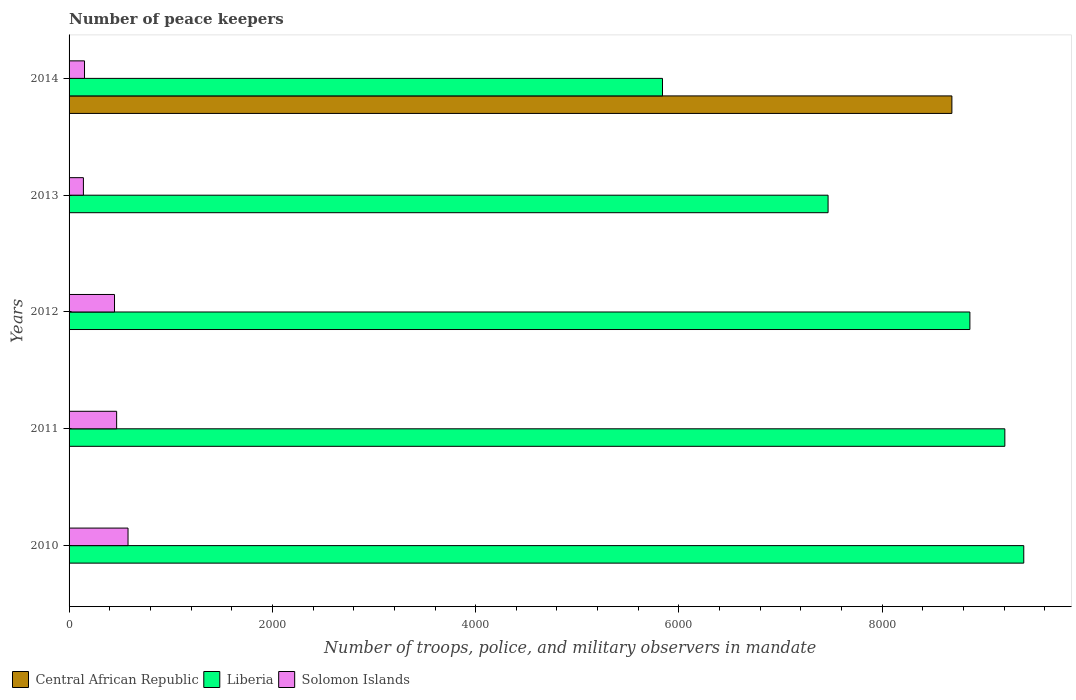How many different coloured bars are there?
Offer a very short reply. 3. Are the number of bars on each tick of the Y-axis equal?
Your answer should be compact. Yes. How many bars are there on the 4th tick from the bottom?
Offer a very short reply. 3. What is the label of the 1st group of bars from the top?
Offer a very short reply. 2014. What is the number of peace keepers in in Solomon Islands in 2012?
Offer a very short reply. 447. Across all years, what is the maximum number of peace keepers in in Central African Republic?
Make the answer very short. 8685. Across all years, what is the minimum number of peace keepers in in Solomon Islands?
Offer a very short reply. 141. What is the total number of peace keepers in in Solomon Islands in the graph?
Ensure brevity in your answer.  1788. What is the difference between the number of peace keepers in in Solomon Islands in 2012 and that in 2013?
Offer a very short reply. 306. What is the difference between the number of peace keepers in in Solomon Islands in 2010 and the number of peace keepers in in Liberia in 2013?
Keep it short and to the point. -6887. What is the average number of peace keepers in in Solomon Islands per year?
Keep it short and to the point. 357.6. In the year 2013, what is the difference between the number of peace keepers in in Solomon Islands and number of peace keepers in in Liberia?
Offer a terse response. -7326. In how many years, is the number of peace keepers in in Solomon Islands greater than 400 ?
Your answer should be very brief. 3. What is the ratio of the number of peace keepers in in Liberia in 2011 to that in 2013?
Offer a terse response. 1.23. What is the difference between the highest and the second highest number of peace keepers in in Solomon Islands?
Keep it short and to the point. 112. What is the difference between the highest and the lowest number of peace keepers in in Central African Republic?
Offer a very short reply. 8682. What does the 2nd bar from the top in 2010 represents?
Keep it short and to the point. Liberia. What does the 2nd bar from the bottom in 2012 represents?
Your answer should be compact. Liberia. Is it the case that in every year, the sum of the number of peace keepers in in Central African Republic and number of peace keepers in in Solomon Islands is greater than the number of peace keepers in in Liberia?
Provide a succinct answer. No. What is the difference between two consecutive major ticks on the X-axis?
Provide a succinct answer. 2000. Are the values on the major ticks of X-axis written in scientific E-notation?
Ensure brevity in your answer.  No. How many legend labels are there?
Ensure brevity in your answer.  3. How are the legend labels stacked?
Offer a terse response. Horizontal. What is the title of the graph?
Provide a succinct answer. Number of peace keepers. What is the label or title of the X-axis?
Keep it short and to the point. Number of troops, police, and military observers in mandate. What is the label or title of the Y-axis?
Your answer should be compact. Years. What is the Number of troops, police, and military observers in mandate in Liberia in 2010?
Your answer should be compact. 9392. What is the Number of troops, police, and military observers in mandate of Solomon Islands in 2010?
Provide a short and direct response. 580. What is the Number of troops, police, and military observers in mandate of Liberia in 2011?
Your answer should be compact. 9206. What is the Number of troops, police, and military observers in mandate of Solomon Islands in 2011?
Ensure brevity in your answer.  468. What is the Number of troops, police, and military observers in mandate of Central African Republic in 2012?
Keep it short and to the point. 4. What is the Number of troops, police, and military observers in mandate of Liberia in 2012?
Offer a very short reply. 8862. What is the Number of troops, police, and military observers in mandate of Solomon Islands in 2012?
Give a very brief answer. 447. What is the Number of troops, police, and military observers in mandate in Central African Republic in 2013?
Offer a terse response. 4. What is the Number of troops, police, and military observers in mandate in Liberia in 2013?
Keep it short and to the point. 7467. What is the Number of troops, police, and military observers in mandate in Solomon Islands in 2013?
Keep it short and to the point. 141. What is the Number of troops, police, and military observers in mandate of Central African Republic in 2014?
Keep it short and to the point. 8685. What is the Number of troops, police, and military observers in mandate in Liberia in 2014?
Ensure brevity in your answer.  5838. What is the Number of troops, police, and military observers in mandate in Solomon Islands in 2014?
Offer a very short reply. 152. Across all years, what is the maximum Number of troops, police, and military observers in mandate of Central African Republic?
Give a very brief answer. 8685. Across all years, what is the maximum Number of troops, police, and military observers in mandate of Liberia?
Your answer should be very brief. 9392. Across all years, what is the maximum Number of troops, police, and military observers in mandate of Solomon Islands?
Your response must be concise. 580. Across all years, what is the minimum Number of troops, police, and military observers in mandate of Central African Republic?
Your response must be concise. 3. Across all years, what is the minimum Number of troops, police, and military observers in mandate of Liberia?
Your response must be concise. 5838. Across all years, what is the minimum Number of troops, police, and military observers in mandate in Solomon Islands?
Make the answer very short. 141. What is the total Number of troops, police, and military observers in mandate in Central African Republic in the graph?
Provide a succinct answer. 8700. What is the total Number of troops, police, and military observers in mandate in Liberia in the graph?
Ensure brevity in your answer.  4.08e+04. What is the total Number of troops, police, and military observers in mandate in Solomon Islands in the graph?
Ensure brevity in your answer.  1788. What is the difference between the Number of troops, police, and military observers in mandate in Central African Republic in 2010 and that in 2011?
Offer a terse response. -1. What is the difference between the Number of troops, police, and military observers in mandate of Liberia in 2010 and that in 2011?
Your answer should be compact. 186. What is the difference between the Number of troops, police, and military observers in mandate of Solomon Islands in 2010 and that in 2011?
Offer a terse response. 112. What is the difference between the Number of troops, police, and military observers in mandate of Central African Republic in 2010 and that in 2012?
Provide a short and direct response. -1. What is the difference between the Number of troops, police, and military observers in mandate in Liberia in 2010 and that in 2012?
Keep it short and to the point. 530. What is the difference between the Number of troops, police, and military observers in mandate of Solomon Islands in 2010 and that in 2012?
Provide a short and direct response. 133. What is the difference between the Number of troops, police, and military observers in mandate in Central African Republic in 2010 and that in 2013?
Provide a short and direct response. -1. What is the difference between the Number of troops, police, and military observers in mandate in Liberia in 2010 and that in 2013?
Offer a terse response. 1925. What is the difference between the Number of troops, police, and military observers in mandate in Solomon Islands in 2010 and that in 2013?
Provide a short and direct response. 439. What is the difference between the Number of troops, police, and military observers in mandate of Central African Republic in 2010 and that in 2014?
Make the answer very short. -8682. What is the difference between the Number of troops, police, and military observers in mandate in Liberia in 2010 and that in 2014?
Ensure brevity in your answer.  3554. What is the difference between the Number of troops, police, and military observers in mandate in Solomon Islands in 2010 and that in 2014?
Keep it short and to the point. 428. What is the difference between the Number of troops, police, and military observers in mandate in Central African Republic in 2011 and that in 2012?
Your answer should be compact. 0. What is the difference between the Number of troops, police, and military observers in mandate in Liberia in 2011 and that in 2012?
Your response must be concise. 344. What is the difference between the Number of troops, police, and military observers in mandate in Central African Republic in 2011 and that in 2013?
Your answer should be very brief. 0. What is the difference between the Number of troops, police, and military observers in mandate of Liberia in 2011 and that in 2013?
Offer a terse response. 1739. What is the difference between the Number of troops, police, and military observers in mandate in Solomon Islands in 2011 and that in 2013?
Keep it short and to the point. 327. What is the difference between the Number of troops, police, and military observers in mandate in Central African Republic in 2011 and that in 2014?
Your answer should be very brief. -8681. What is the difference between the Number of troops, police, and military observers in mandate in Liberia in 2011 and that in 2014?
Offer a very short reply. 3368. What is the difference between the Number of troops, police, and military observers in mandate in Solomon Islands in 2011 and that in 2014?
Make the answer very short. 316. What is the difference between the Number of troops, police, and military observers in mandate of Central African Republic in 2012 and that in 2013?
Your answer should be compact. 0. What is the difference between the Number of troops, police, and military observers in mandate in Liberia in 2012 and that in 2013?
Offer a very short reply. 1395. What is the difference between the Number of troops, police, and military observers in mandate of Solomon Islands in 2012 and that in 2013?
Provide a succinct answer. 306. What is the difference between the Number of troops, police, and military observers in mandate in Central African Republic in 2012 and that in 2014?
Provide a succinct answer. -8681. What is the difference between the Number of troops, police, and military observers in mandate of Liberia in 2012 and that in 2014?
Your answer should be very brief. 3024. What is the difference between the Number of troops, police, and military observers in mandate of Solomon Islands in 2012 and that in 2014?
Make the answer very short. 295. What is the difference between the Number of troops, police, and military observers in mandate of Central African Republic in 2013 and that in 2014?
Your answer should be very brief. -8681. What is the difference between the Number of troops, police, and military observers in mandate of Liberia in 2013 and that in 2014?
Offer a very short reply. 1629. What is the difference between the Number of troops, police, and military observers in mandate of Solomon Islands in 2013 and that in 2014?
Provide a short and direct response. -11. What is the difference between the Number of troops, police, and military observers in mandate in Central African Republic in 2010 and the Number of troops, police, and military observers in mandate in Liberia in 2011?
Ensure brevity in your answer.  -9203. What is the difference between the Number of troops, police, and military observers in mandate of Central African Republic in 2010 and the Number of troops, police, and military observers in mandate of Solomon Islands in 2011?
Ensure brevity in your answer.  -465. What is the difference between the Number of troops, police, and military observers in mandate in Liberia in 2010 and the Number of troops, police, and military observers in mandate in Solomon Islands in 2011?
Provide a short and direct response. 8924. What is the difference between the Number of troops, police, and military observers in mandate of Central African Republic in 2010 and the Number of troops, police, and military observers in mandate of Liberia in 2012?
Give a very brief answer. -8859. What is the difference between the Number of troops, police, and military observers in mandate in Central African Republic in 2010 and the Number of troops, police, and military observers in mandate in Solomon Islands in 2012?
Your answer should be compact. -444. What is the difference between the Number of troops, police, and military observers in mandate in Liberia in 2010 and the Number of troops, police, and military observers in mandate in Solomon Islands in 2012?
Provide a succinct answer. 8945. What is the difference between the Number of troops, police, and military observers in mandate of Central African Republic in 2010 and the Number of troops, police, and military observers in mandate of Liberia in 2013?
Your answer should be very brief. -7464. What is the difference between the Number of troops, police, and military observers in mandate of Central African Republic in 2010 and the Number of troops, police, and military observers in mandate of Solomon Islands in 2013?
Your response must be concise. -138. What is the difference between the Number of troops, police, and military observers in mandate of Liberia in 2010 and the Number of troops, police, and military observers in mandate of Solomon Islands in 2013?
Your answer should be very brief. 9251. What is the difference between the Number of troops, police, and military observers in mandate of Central African Republic in 2010 and the Number of troops, police, and military observers in mandate of Liberia in 2014?
Give a very brief answer. -5835. What is the difference between the Number of troops, police, and military observers in mandate of Central African Republic in 2010 and the Number of troops, police, and military observers in mandate of Solomon Islands in 2014?
Give a very brief answer. -149. What is the difference between the Number of troops, police, and military observers in mandate in Liberia in 2010 and the Number of troops, police, and military observers in mandate in Solomon Islands in 2014?
Offer a terse response. 9240. What is the difference between the Number of troops, police, and military observers in mandate in Central African Republic in 2011 and the Number of troops, police, and military observers in mandate in Liberia in 2012?
Make the answer very short. -8858. What is the difference between the Number of troops, police, and military observers in mandate in Central African Republic in 2011 and the Number of troops, police, and military observers in mandate in Solomon Islands in 2012?
Give a very brief answer. -443. What is the difference between the Number of troops, police, and military observers in mandate in Liberia in 2011 and the Number of troops, police, and military observers in mandate in Solomon Islands in 2012?
Your answer should be compact. 8759. What is the difference between the Number of troops, police, and military observers in mandate of Central African Republic in 2011 and the Number of troops, police, and military observers in mandate of Liberia in 2013?
Your answer should be compact. -7463. What is the difference between the Number of troops, police, and military observers in mandate of Central African Republic in 2011 and the Number of troops, police, and military observers in mandate of Solomon Islands in 2013?
Make the answer very short. -137. What is the difference between the Number of troops, police, and military observers in mandate of Liberia in 2011 and the Number of troops, police, and military observers in mandate of Solomon Islands in 2013?
Provide a short and direct response. 9065. What is the difference between the Number of troops, police, and military observers in mandate in Central African Republic in 2011 and the Number of troops, police, and military observers in mandate in Liberia in 2014?
Offer a very short reply. -5834. What is the difference between the Number of troops, police, and military observers in mandate of Central African Republic in 2011 and the Number of troops, police, and military observers in mandate of Solomon Islands in 2014?
Give a very brief answer. -148. What is the difference between the Number of troops, police, and military observers in mandate of Liberia in 2011 and the Number of troops, police, and military observers in mandate of Solomon Islands in 2014?
Ensure brevity in your answer.  9054. What is the difference between the Number of troops, police, and military observers in mandate of Central African Republic in 2012 and the Number of troops, police, and military observers in mandate of Liberia in 2013?
Offer a very short reply. -7463. What is the difference between the Number of troops, police, and military observers in mandate in Central African Republic in 2012 and the Number of troops, police, and military observers in mandate in Solomon Islands in 2013?
Your answer should be compact. -137. What is the difference between the Number of troops, police, and military observers in mandate of Liberia in 2012 and the Number of troops, police, and military observers in mandate of Solomon Islands in 2013?
Offer a terse response. 8721. What is the difference between the Number of troops, police, and military observers in mandate in Central African Republic in 2012 and the Number of troops, police, and military observers in mandate in Liberia in 2014?
Offer a very short reply. -5834. What is the difference between the Number of troops, police, and military observers in mandate in Central African Republic in 2012 and the Number of troops, police, and military observers in mandate in Solomon Islands in 2014?
Your answer should be very brief. -148. What is the difference between the Number of troops, police, and military observers in mandate in Liberia in 2012 and the Number of troops, police, and military observers in mandate in Solomon Islands in 2014?
Your answer should be very brief. 8710. What is the difference between the Number of troops, police, and military observers in mandate of Central African Republic in 2013 and the Number of troops, police, and military observers in mandate of Liberia in 2014?
Your response must be concise. -5834. What is the difference between the Number of troops, police, and military observers in mandate in Central African Republic in 2013 and the Number of troops, police, and military observers in mandate in Solomon Islands in 2014?
Offer a terse response. -148. What is the difference between the Number of troops, police, and military observers in mandate in Liberia in 2013 and the Number of troops, police, and military observers in mandate in Solomon Islands in 2014?
Provide a short and direct response. 7315. What is the average Number of troops, police, and military observers in mandate of Central African Republic per year?
Your answer should be very brief. 1740. What is the average Number of troops, police, and military observers in mandate in Liberia per year?
Offer a very short reply. 8153. What is the average Number of troops, police, and military observers in mandate in Solomon Islands per year?
Provide a succinct answer. 357.6. In the year 2010, what is the difference between the Number of troops, police, and military observers in mandate in Central African Republic and Number of troops, police, and military observers in mandate in Liberia?
Your response must be concise. -9389. In the year 2010, what is the difference between the Number of troops, police, and military observers in mandate in Central African Republic and Number of troops, police, and military observers in mandate in Solomon Islands?
Your response must be concise. -577. In the year 2010, what is the difference between the Number of troops, police, and military observers in mandate in Liberia and Number of troops, police, and military observers in mandate in Solomon Islands?
Offer a terse response. 8812. In the year 2011, what is the difference between the Number of troops, police, and military observers in mandate of Central African Republic and Number of troops, police, and military observers in mandate of Liberia?
Keep it short and to the point. -9202. In the year 2011, what is the difference between the Number of troops, police, and military observers in mandate in Central African Republic and Number of troops, police, and military observers in mandate in Solomon Islands?
Make the answer very short. -464. In the year 2011, what is the difference between the Number of troops, police, and military observers in mandate of Liberia and Number of troops, police, and military observers in mandate of Solomon Islands?
Offer a terse response. 8738. In the year 2012, what is the difference between the Number of troops, police, and military observers in mandate of Central African Republic and Number of troops, police, and military observers in mandate of Liberia?
Your answer should be very brief. -8858. In the year 2012, what is the difference between the Number of troops, police, and military observers in mandate in Central African Republic and Number of troops, police, and military observers in mandate in Solomon Islands?
Your answer should be compact. -443. In the year 2012, what is the difference between the Number of troops, police, and military observers in mandate in Liberia and Number of troops, police, and military observers in mandate in Solomon Islands?
Provide a succinct answer. 8415. In the year 2013, what is the difference between the Number of troops, police, and military observers in mandate of Central African Republic and Number of troops, police, and military observers in mandate of Liberia?
Offer a very short reply. -7463. In the year 2013, what is the difference between the Number of troops, police, and military observers in mandate of Central African Republic and Number of troops, police, and military observers in mandate of Solomon Islands?
Provide a short and direct response. -137. In the year 2013, what is the difference between the Number of troops, police, and military observers in mandate of Liberia and Number of troops, police, and military observers in mandate of Solomon Islands?
Give a very brief answer. 7326. In the year 2014, what is the difference between the Number of troops, police, and military observers in mandate in Central African Republic and Number of troops, police, and military observers in mandate in Liberia?
Offer a very short reply. 2847. In the year 2014, what is the difference between the Number of troops, police, and military observers in mandate in Central African Republic and Number of troops, police, and military observers in mandate in Solomon Islands?
Offer a very short reply. 8533. In the year 2014, what is the difference between the Number of troops, police, and military observers in mandate of Liberia and Number of troops, police, and military observers in mandate of Solomon Islands?
Your response must be concise. 5686. What is the ratio of the Number of troops, police, and military observers in mandate of Central African Republic in 2010 to that in 2011?
Give a very brief answer. 0.75. What is the ratio of the Number of troops, police, and military observers in mandate of Liberia in 2010 to that in 2011?
Keep it short and to the point. 1.02. What is the ratio of the Number of troops, police, and military observers in mandate of Solomon Islands in 2010 to that in 2011?
Offer a terse response. 1.24. What is the ratio of the Number of troops, police, and military observers in mandate of Central African Republic in 2010 to that in 2012?
Make the answer very short. 0.75. What is the ratio of the Number of troops, police, and military observers in mandate of Liberia in 2010 to that in 2012?
Offer a terse response. 1.06. What is the ratio of the Number of troops, police, and military observers in mandate of Solomon Islands in 2010 to that in 2012?
Your response must be concise. 1.3. What is the ratio of the Number of troops, police, and military observers in mandate of Liberia in 2010 to that in 2013?
Offer a terse response. 1.26. What is the ratio of the Number of troops, police, and military observers in mandate in Solomon Islands in 2010 to that in 2013?
Provide a short and direct response. 4.11. What is the ratio of the Number of troops, police, and military observers in mandate of Liberia in 2010 to that in 2014?
Provide a short and direct response. 1.61. What is the ratio of the Number of troops, police, and military observers in mandate of Solomon Islands in 2010 to that in 2014?
Provide a short and direct response. 3.82. What is the ratio of the Number of troops, police, and military observers in mandate in Central African Republic in 2011 to that in 2012?
Ensure brevity in your answer.  1. What is the ratio of the Number of troops, police, and military observers in mandate of Liberia in 2011 to that in 2012?
Offer a terse response. 1.04. What is the ratio of the Number of troops, police, and military observers in mandate in Solomon Islands in 2011 to that in 2012?
Your answer should be very brief. 1.05. What is the ratio of the Number of troops, police, and military observers in mandate of Central African Republic in 2011 to that in 2013?
Provide a short and direct response. 1. What is the ratio of the Number of troops, police, and military observers in mandate in Liberia in 2011 to that in 2013?
Make the answer very short. 1.23. What is the ratio of the Number of troops, police, and military observers in mandate of Solomon Islands in 2011 to that in 2013?
Offer a terse response. 3.32. What is the ratio of the Number of troops, police, and military observers in mandate of Liberia in 2011 to that in 2014?
Make the answer very short. 1.58. What is the ratio of the Number of troops, police, and military observers in mandate in Solomon Islands in 2011 to that in 2014?
Your response must be concise. 3.08. What is the ratio of the Number of troops, police, and military observers in mandate in Liberia in 2012 to that in 2013?
Keep it short and to the point. 1.19. What is the ratio of the Number of troops, police, and military observers in mandate of Solomon Islands in 2012 to that in 2013?
Make the answer very short. 3.17. What is the ratio of the Number of troops, police, and military observers in mandate in Central African Republic in 2012 to that in 2014?
Provide a succinct answer. 0. What is the ratio of the Number of troops, police, and military observers in mandate of Liberia in 2012 to that in 2014?
Offer a terse response. 1.52. What is the ratio of the Number of troops, police, and military observers in mandate of Solomon Islands in 2012 to that in 2014?
Ensure brevity in your answer.  2.94. What is the ratio of the Number of troops, police, and military observers in mandate of Central African Republic in 2013 to that in 2014?
Offer a terse response. 0. What is the ratio of the Number of troops, police, and military observers in mandate in Liberia in 2013 to that in 2014?
Offer a terse response. 1.28. What is the ratio of the Number of troops, police, and military observers in mandate in Solomon Islands in 2013 to that in 2014?
Offer a terse response. 0.93. What is the difference between the highest and the second highest Number of troops, police, and military observers in mandate of Central African Republic?
Provide a succinct answer. 8681. What is the difference between the highest and the second highest Number of troops, police, and military observers in mandate in Liberia?
Provide a succinct answer. 186. What is the difference between the highest and the second highest Number of troops, police, and military observers in mandate of Solomon Islands?
Give a very brief answer. 112. What is the difference between the highest and the lowest Number of troops, police, and military observers in mandate in Central African Republic?
Make the answer very short. 8682. What is the difference between the highest and the lowest Number of troops, police, and military observers in mandate in Liberia?
Your answer should be very brief. 3554. What is the difference between the highest and the lowest Number of troops, police, and military observers in mandate of Solomon Islands?
Provide a short and direct response. 439. 